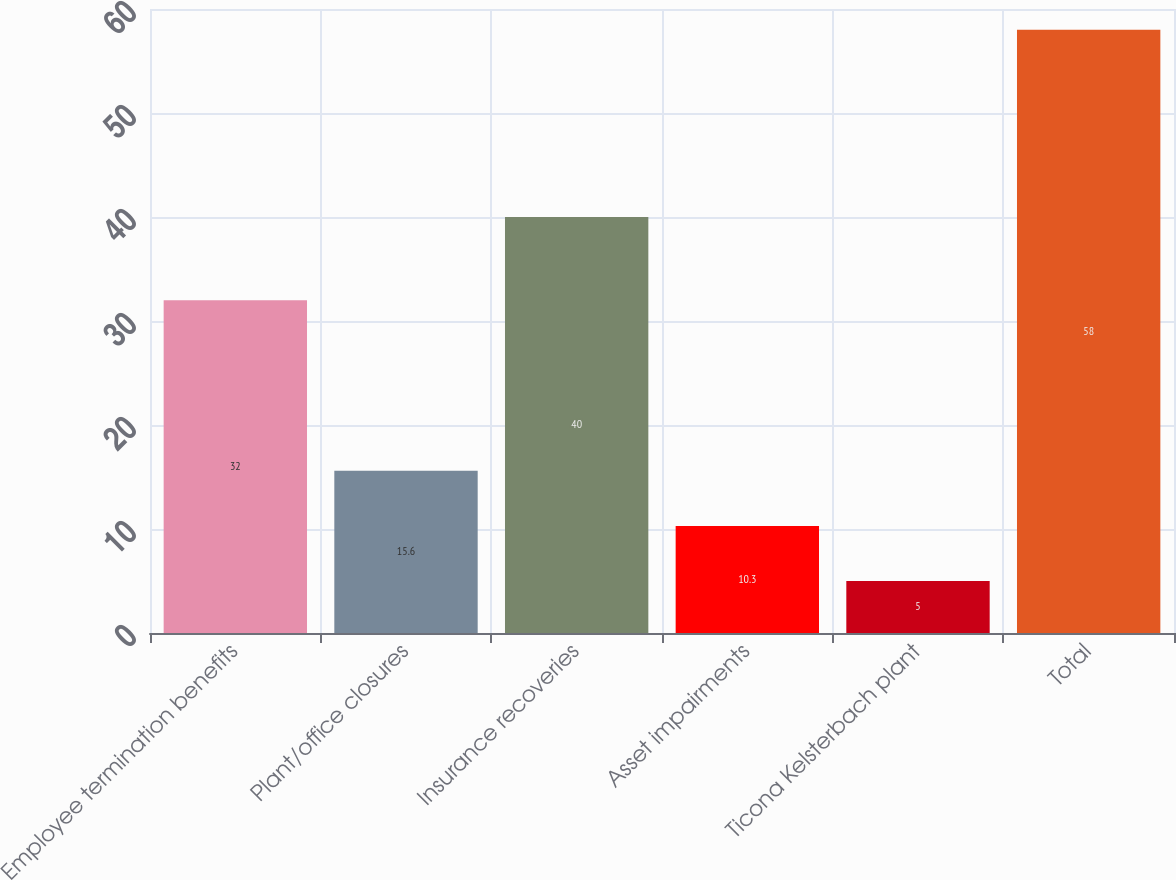Convert chart. <chart><loc_0><loc_0><loc_500><loc_500><bar_chart><fcel>Employee termination benefits<fcel>Plant/office closures<fcel>Insurance recoveries<fcel>Asset impairments<fcel>Ticona Kelsterbach plant<fcel>Total<nl><fcel>32<fcel>15.6<fcel>40<fcel>10.3<fcel>5<fcel>58<nl></chart> 